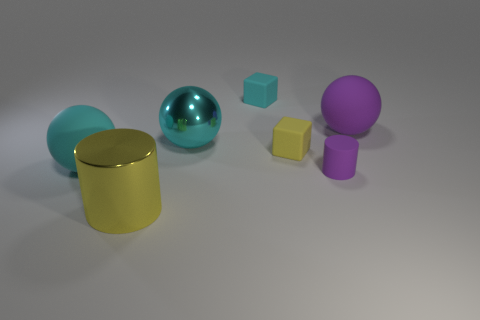Subtract all cyan spheres. How many spheres are left? 1 Subtract 1 cubes. How many cubes are left? 1 Subtract all purple balls. How many balls are left? 2 Add 2 big cyan metallic spheres. How many objects exist? 9 Subtract all blocks. How many objects are left? 5 Subtract all purple balls. How many brown cubes are left? 0 Subtract all yellow cubes. Subtract all green cylinders. How many cubes are left? 1 Subtract all brown objects. Subtract all purple matte spheres. How many objects are left? 6 Add 3 large cyan metallic objects. How many large cyan metallic objects are left? 4 Add 5 large cyan matte cylinders. How many large cyan matte cylinders exist? 5 